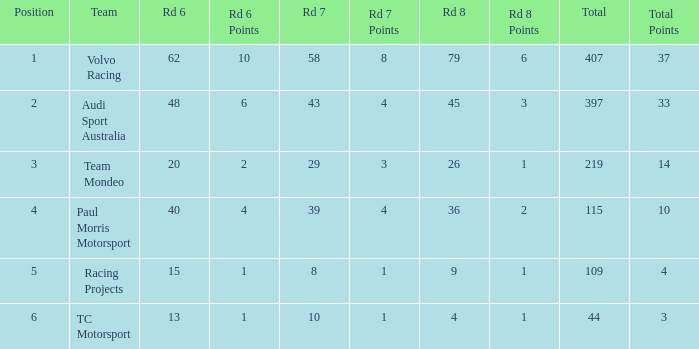Can you give me this table as a dict? {'header': ['Position', 'Team', 'Rd 6', 'Rd 6 Points', 'Rd 7', 'Rd 7 Points', 'Rd 8', 'Rd 8 Points', 'Total', 'Total Points'], 'rows': [['1', 'Volvo Racing', '62', '10', '58', '8', '79', '6', '407', '37'], ['2', 'Audi Sport Australia', '48', '6', '43', '4', '45', '3', '397', '33'], ['3', 'Team Mondeo', '20', '2', '29', '3', '26', '1', '219', '14'], ['4', 'Paul Morris Motorsport', '40', '4', '39', '4', '36', '2', '115', '10'], ['5', 'Racing Projects', '15', '1', '8', '1', '9', '1', '109', '4'], ['6', 'TC Motorsport', '13', '1', '10', '1', '4', '1', '44', '3']]} What is the sum of total values for Rd 7 less than 8? None. 